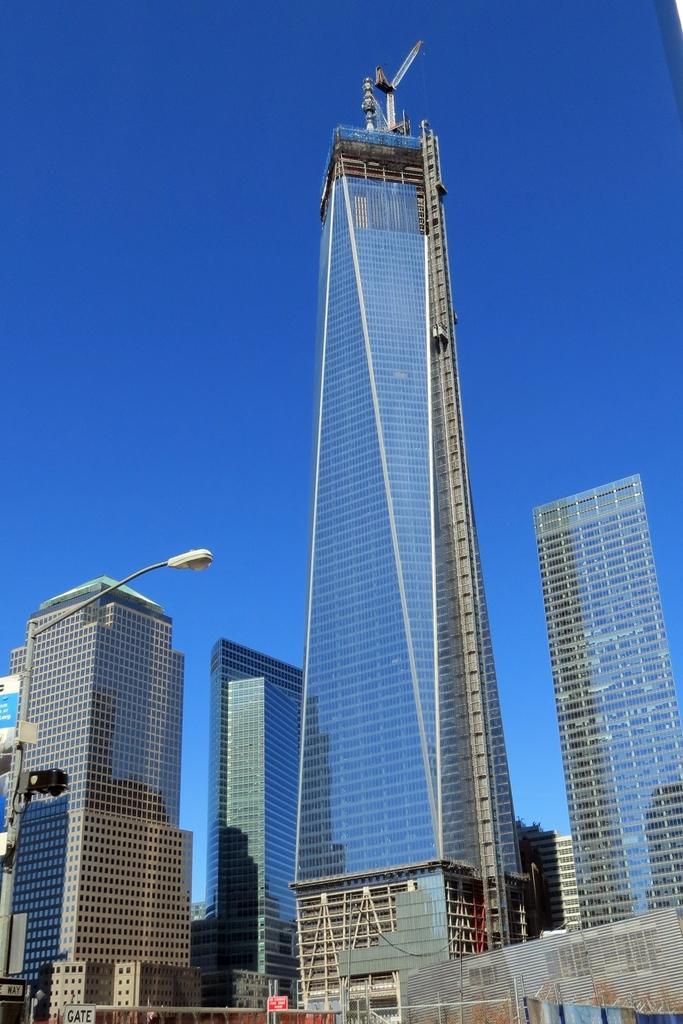Could you give a brief overview of what you see in this image? This picture might be taken from outside of the building. In this image, on the left side, we can see a street light and hoardings. In the background, there are some buildings, trees. On the top, we can see a sky. 